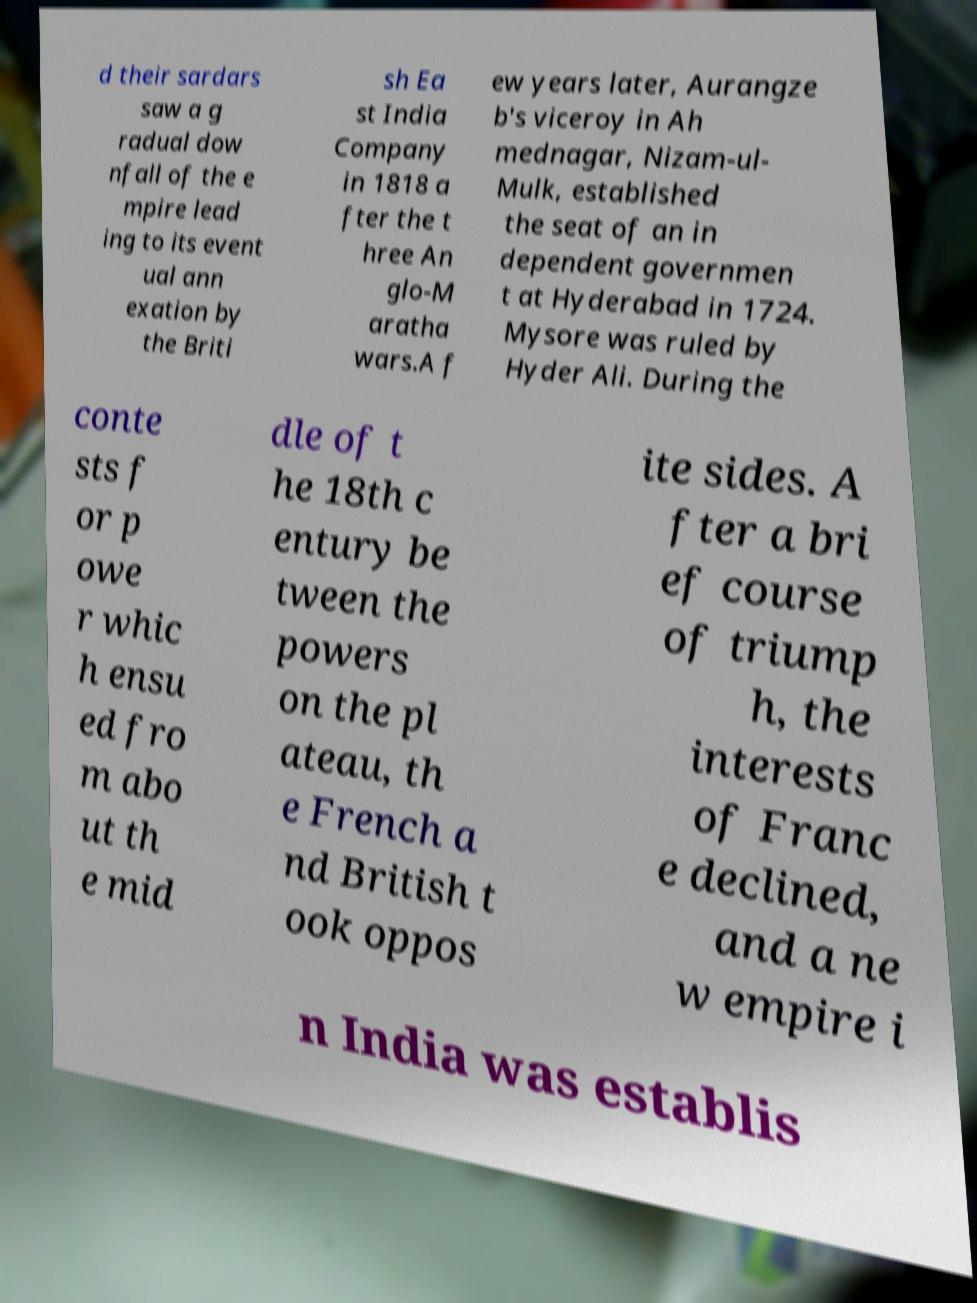Could you assist in decoding the text presented in this image and type it out clearly? d their sardars saw a g radual dow nfall of the e mpire lead ing to its event ual ann exation by the Briti sh Ea st India Company in 1818 a fter the t hree An glo-M aratha wars.A f ew years later, Aurangze b's viceroy in Ah mednagar, Nizam-ul- Mulk, established the seat of an in dependent governmen t at Hyderabad in 1724. Mysore was ruled by Hyder Ali. During the conte sts f or p owe r whic h ensu ed fro m abo ut th e mid dle of t he 18th c entury be tween the powers on the pl ateau, th e French a nd British t ook oppos ite sides. A fter a bri ef course of triump h, the interests of Franc e declined, and a ne w empire i n India was establis 